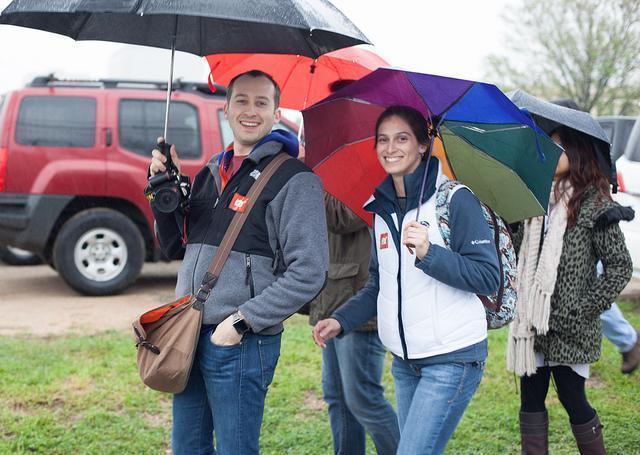How many umbrellas can you see?
Give a very brief answer. 3. How many people are there?
Give a very brief answer. 4. How many elephants are on the right page?
Give a very brief answer. 0. 